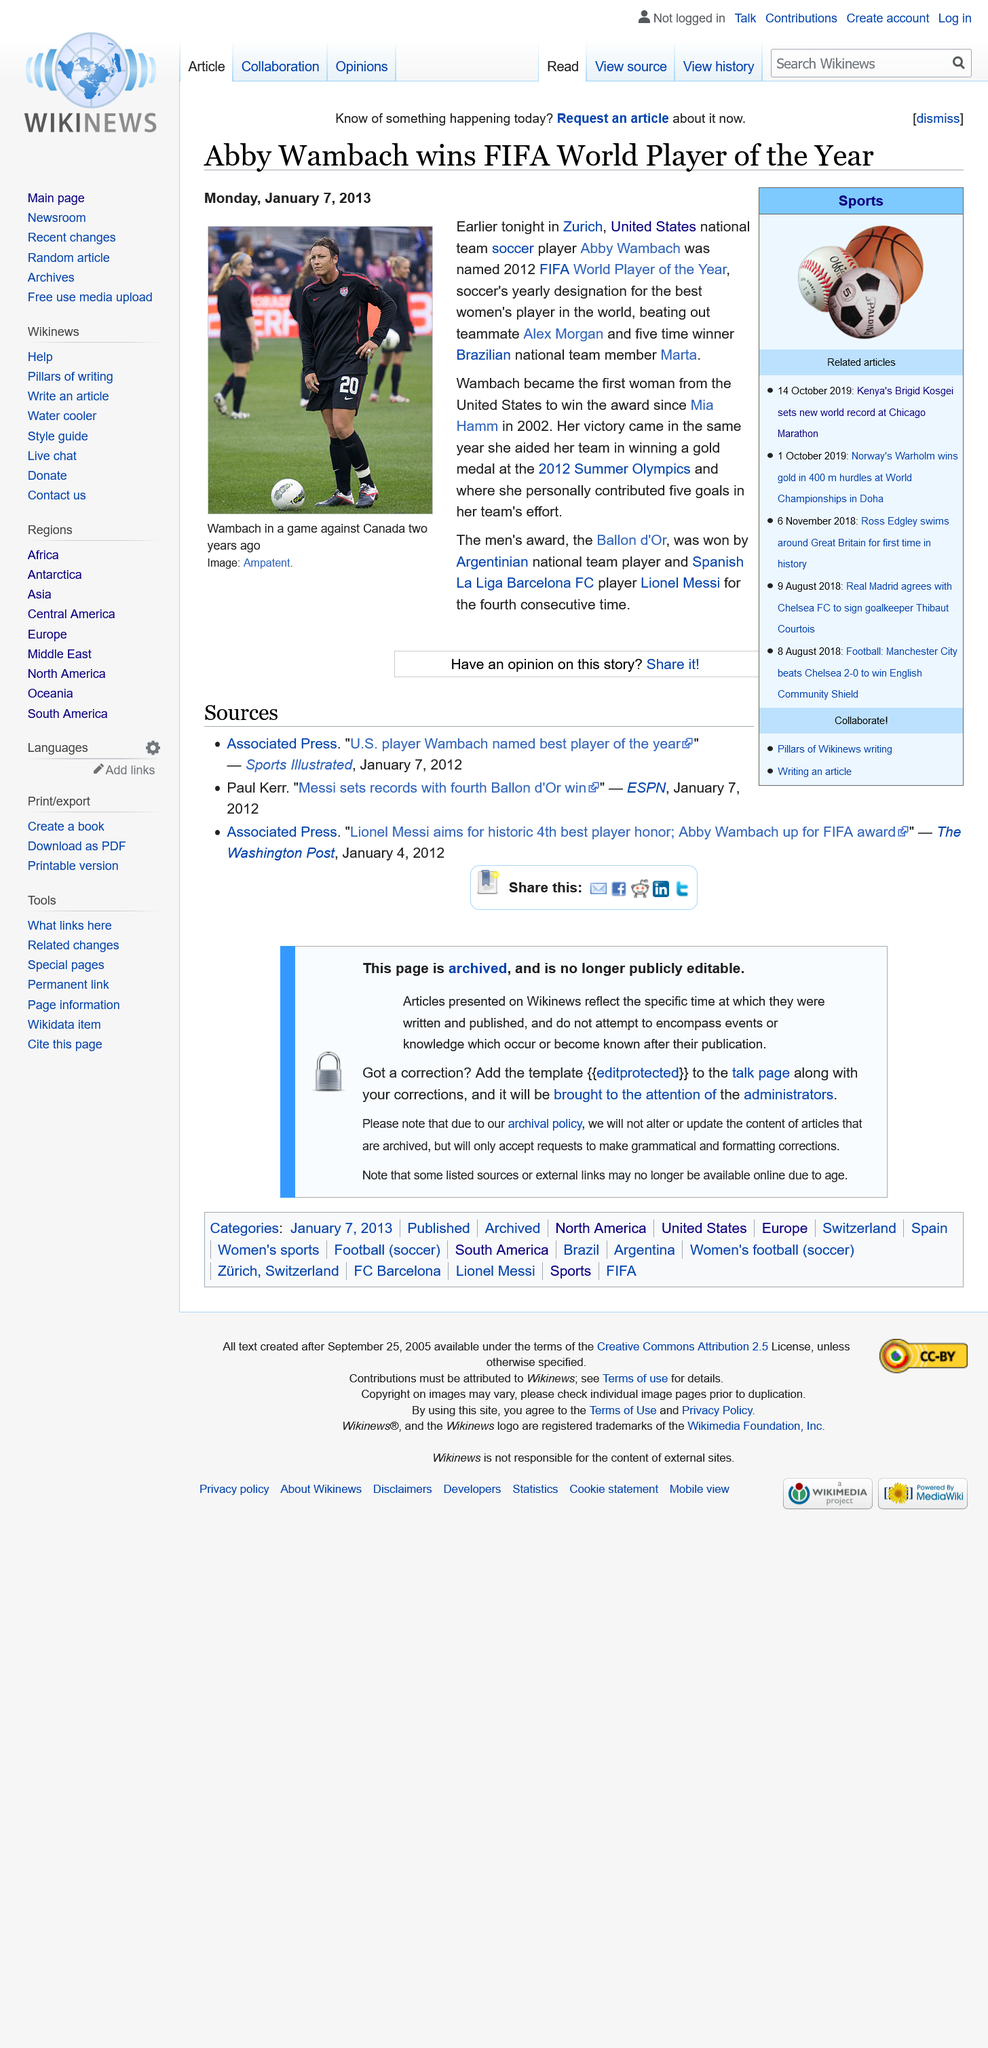Highlight a few significant elements in this photo. Abby Wambach was in the picture. The article was published on July 1, 2013. The speaker is asking a question about a person who was given an award in 2012. The award was the FIFA World Player of the Year. 